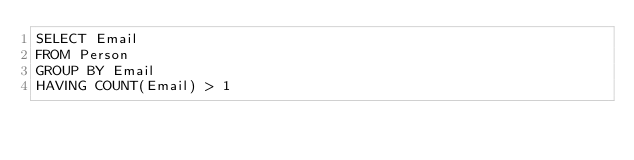<code> <loc_0><loc_0><loc_500><loc_500><_SQL_>SELECT Email
FROM Person
GROUP BY Email
HAVING COUNT(Email) > 1</code> 